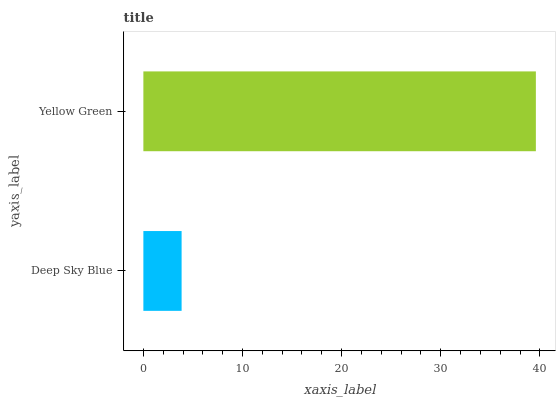Is Deep Sky Blue the minimum?
Answer yes or no. Yes. Is Yellow Green the maximum?
Answer yes or no. Yes. Is Yellow Green the minimum?
Answer yes or no. No. Is Yellow Green greater than Deep Sky Blue?
Answer yes or no. Yes. Is Deep Sky Blue less than Yellow Green?
Answer yes or no. Yes. Is Deep Sky Blue greater than Yellow Green?
Answer yes or no. No. Is Yellow Green less than Deep Sky Blue?
Answer yes or no. No. Is Yellow Green the high median?
Answer yes or no. Yes. Is Deep Sky Blue the low median?
Answer yes or no. Yes. Is Deep Sky Blue the high median?
Answer yes or no. No. Is Yellow Green the low median?
Answer yes or no. No. 